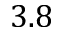<formula> <loc_0><loc_0><loc_500><loc_500>3 . 8</formula> 